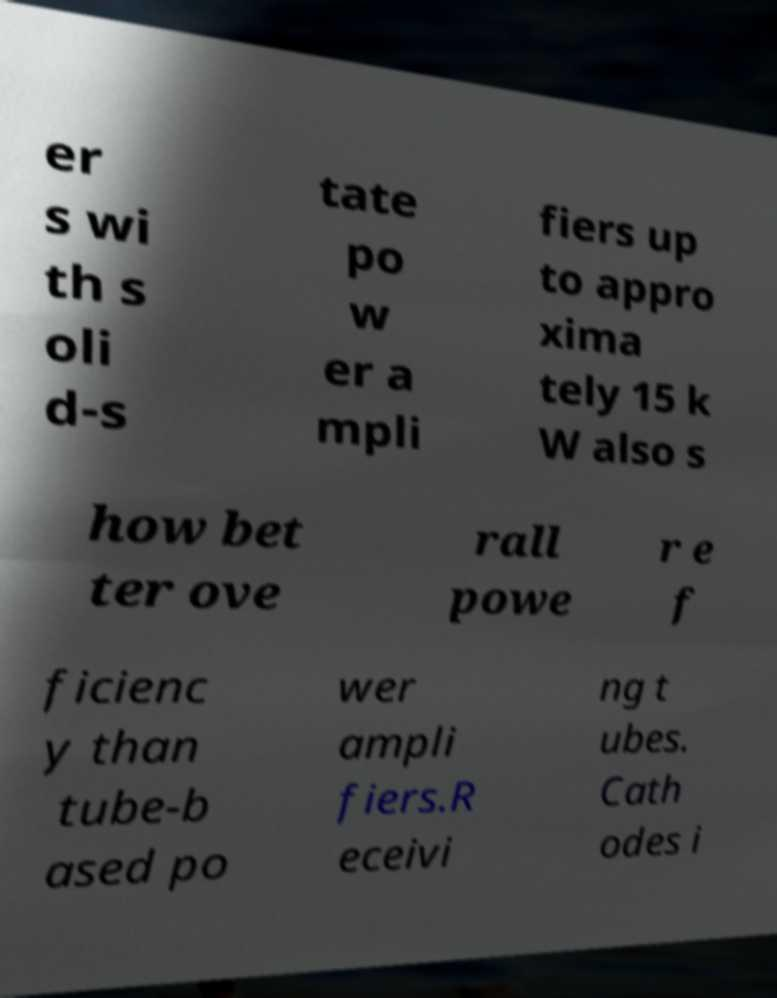For documentation purposes, I need the text within this image transcribed. Could you provide that? er s wi th s oli d-s tate po w er a mpli fiers up to appro xima tely 15 k W also s how bet ter ove rall powe r e f ficienc y than tube-b ased po wer ampli fiers.R eceivi ng t ubes. Cath odes i 